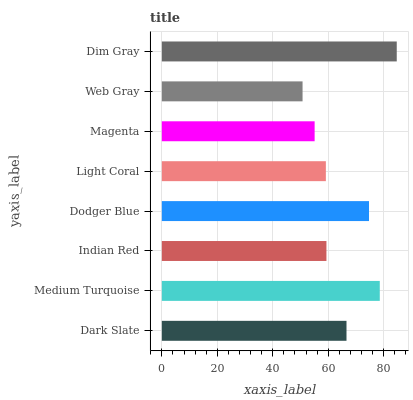Is Web Gray the minimum?
Answer yes or no. Yes. Is Dim Gray the maximum?
Answer yes or no. Yes. Is Medium Turquoise the minimum?
Answer yes or no. No. Is Medium Turquoise the maximum?
Answer yes or no. No. Is Medium Turquoise greater than Dark Slate?
Answer yes or no. Yes. Is Dark Slate less than Medium Turquoise?
Answer yes or no. Yes. Is Dark Slate greater than Medium Turquoise?
Answer yes or no. No. Is Medium Turquoise less than Dark Slate?
Answer yes or no. No. Is Dark Slate the high median?
Answer yes or no. Yes. Is Indian Red the low median?
Answer yes or no. Yes. Is Dodger Blue the high median?
Answer yes or no. No. Is Dodger Blue the low median?
Answer yes or no. No. 